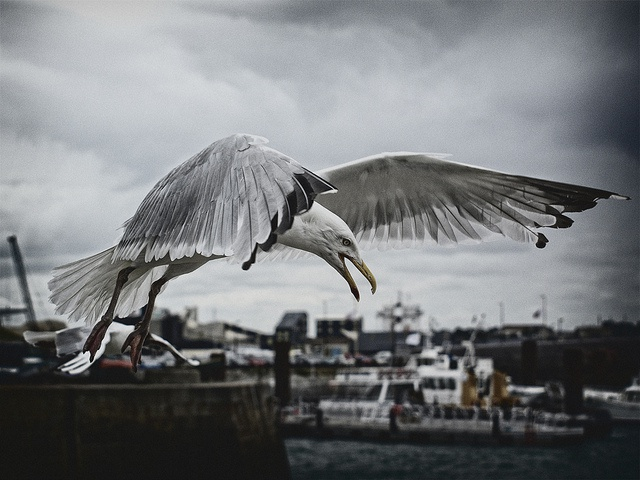Describe the objects in this image and their specific colors. I can see bird in gray, darkgray, black, and lightgray tones, boat in gray, black, and darkgray tones, boat in gray, black, darkgray, and lightgray tones, boat in gray, black, and darkgray tones, and boat in gray, darkgray, black, and lightgray tones in this image. 